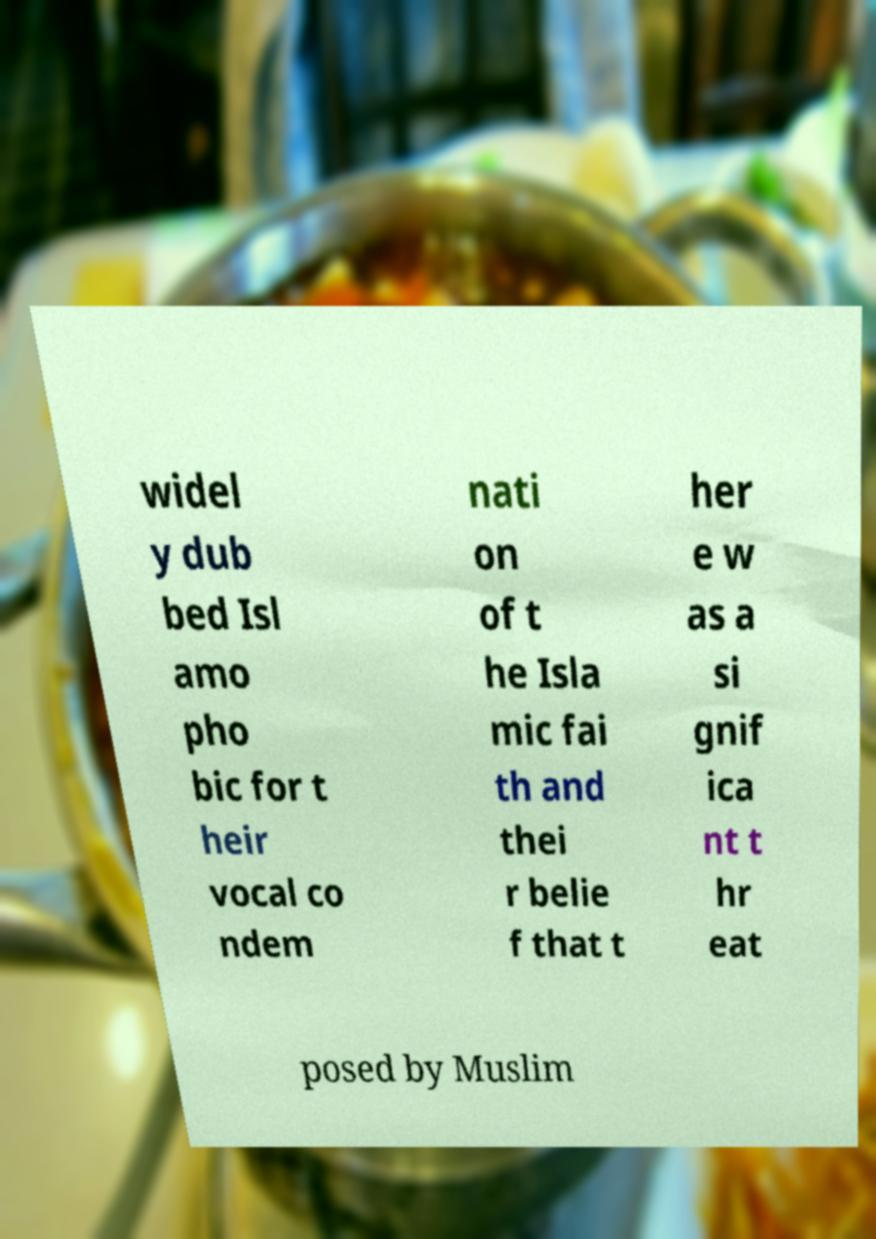Please identify and transcribe the text found in this image. widel y dub bed Isl amo pho bic for t heir vocal co ndem nati on of t he Isla mic fai th and thei r belie f that t her e w as a si gnif ica nt t hr eat posed by Muslim 